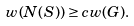<formula> <loc_0><loc_0><loc_500><loc_500>w ( N ( S ) ) \geq c w ( G ) .</formula> 